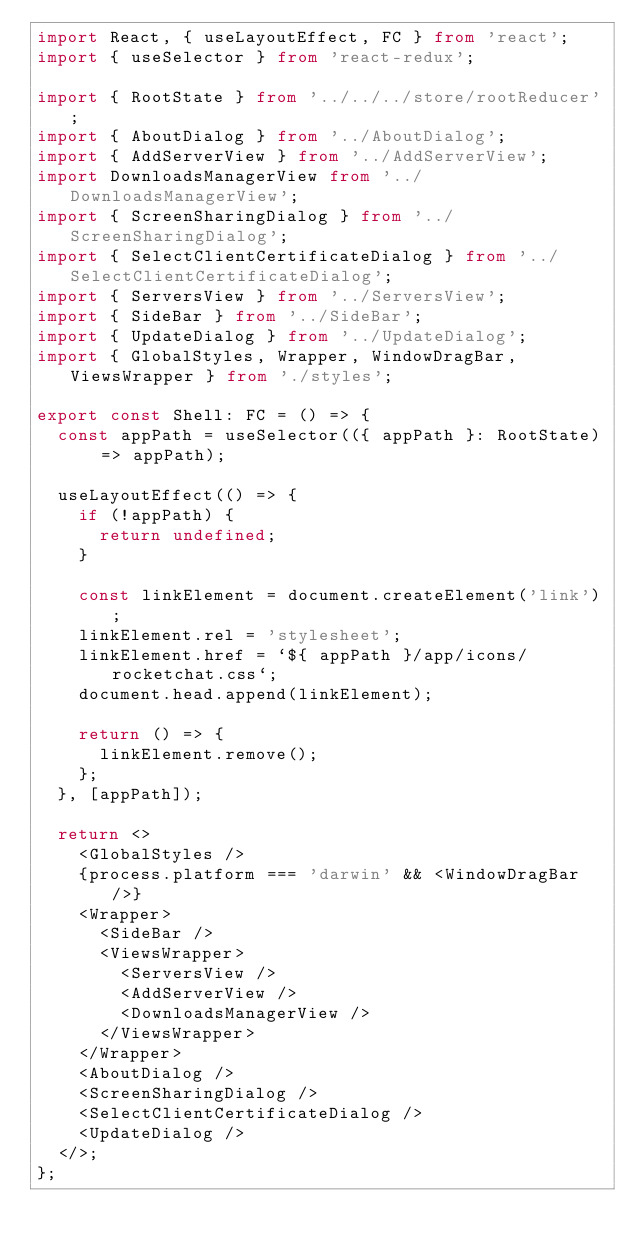Convert code to text. <code><loc_0><loc_0><loc_500><loc_500><_TypeScript_>import React, { useLayoutEffect, FC } from 'react';
import { useSelector } from 'react-redux';

import { RootState } from '../../../store/rootReducer';
import { AboutDialog } from '../AboutDialog';
import { AddServerView } from '../AddServerView';
import DownloadsManagerView from '../DownloadsManagerView';
import { ScreenSharingDialog } from '../ScreenSharingDialog';
import { SelectClientCertificateDialog } from '../SelectClientCertificateDialog';
import { ServersView } from '../ServersView';
import { SideBar } from '../SideBar';
import { UpdateDialog } from '../UpdateDialog';
import { GlobalStyles, Wrapper, WindowDragBar, ViewsWrapper } from './styles';

export const Shell: FC = () => {
  const appPath = useSelector(({ appPath }: RootState) => appPath);

  useLayoutEffect(() => {
    if (!appPath) {
      return undefined;
    }

    const linkElement = document.createElement('link');
    linkElement.rel = 'stylesheet';
    linkElement.href = `${ appPath }/app/icons/rocketchat.css`;
    document.head.append(linkElement);

    return () => {
      linkElement.remove();
    };
  }, [appPath]);

  return <>
    <GlobalStyles />
    {process.platform === 'darwin' && <WindowDragBar />}
    <Wrapper>
      <SideBar />
      <ViewsWrapper>
        <ServersView />
        <AddServerView />
        <DownloadsManagerView />
      </ViewsWrapper>
    </Wrapper>
    <AboutDialog />
    <ScreenSharingDialog />
    <SelectClientCertificateDialog />
    <UpdateDialog />
  </>;
};
</code> 